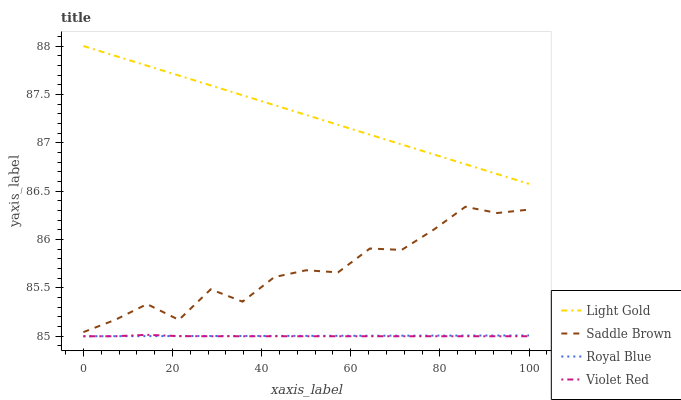Does Violet Red have the minimum area under the curve?
Answer yes or no. Yes. Does Light Gold have the maximum area under the curve?
Answer yes or no. Yes. Does Light Gold have the minimum area under the curve?
Answer yes or no. No. Does Violet Red have the maximum area under the curve?
Answer yes or no. No. Is Light Gold the smoothest?
Answer yes or no. Yes. Is Saddle Brown the roughest?
Answer yes or no. Yes. Is Violet Red the smoothest?
Answer yes or no. No. Is Violet Red the roughest?
Answer yes or no. No. Does Royal Blue have the lowest value?
Answer yes or no. Yes. Does Light Gold have the lowest value?
Answer yes or no. No. Does Light Gold have the highest value?
Answer yes or no. Yes. Does Violet Red have the highest value?
Answer yes or no. No. Is Violet Red less than Light Gold?
Answer yes or no. Yes. Is Light Gold greater than Royal Blue?
Answer yes or no. Yes. Does Royal Blue intersect Violet Red?
Answer yes or no. Yes. Is Royal Blue less than Violet Red?
Answer yes or no. No. Is Royal Blue greater than Violet Red?
Answer yes or no. No. Does Violet Red intersect Light Gold?
Answer yes or no. No. 